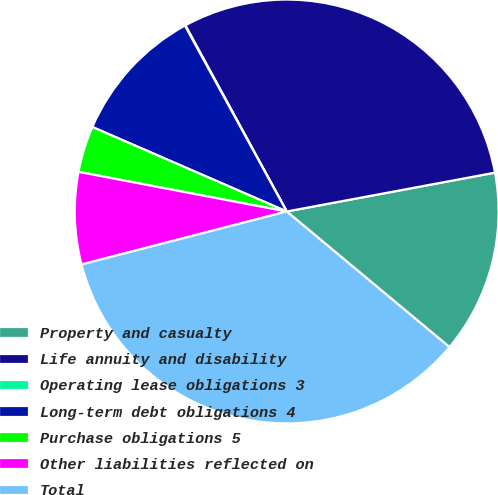Convert chart. <chart><loc_0><loc_0><loc_500><loc_500><pie_chart><fcel>Property and casualty<fcel>Life annuity and disability<fcel>Operating lease obligations 3<fcel>Long-term debt obligations 4<fcel>Purchase obligations 5<fcel>Other liabilities reflected on<fcel>Total<nl><fcel>13.99%<fcel>30.0%<fcel>0.04%<fcel>10.5%<fcel>3.53%<fcel>7.02%<fcel>34.92%<nl></chart> 